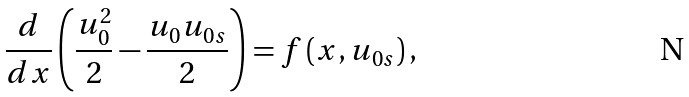<formula> <loc_0><loc_0><loc_500><loc_500>\frac { d } { d x } \left ( \frac { u _ { 0 } ^ { 2 } } { 2 } - \frac { u _ { 0 } u _ { 0 s } } { 2 } \right ) = f \left ( x , u _ { 0 s } \right ) ,</formula> 